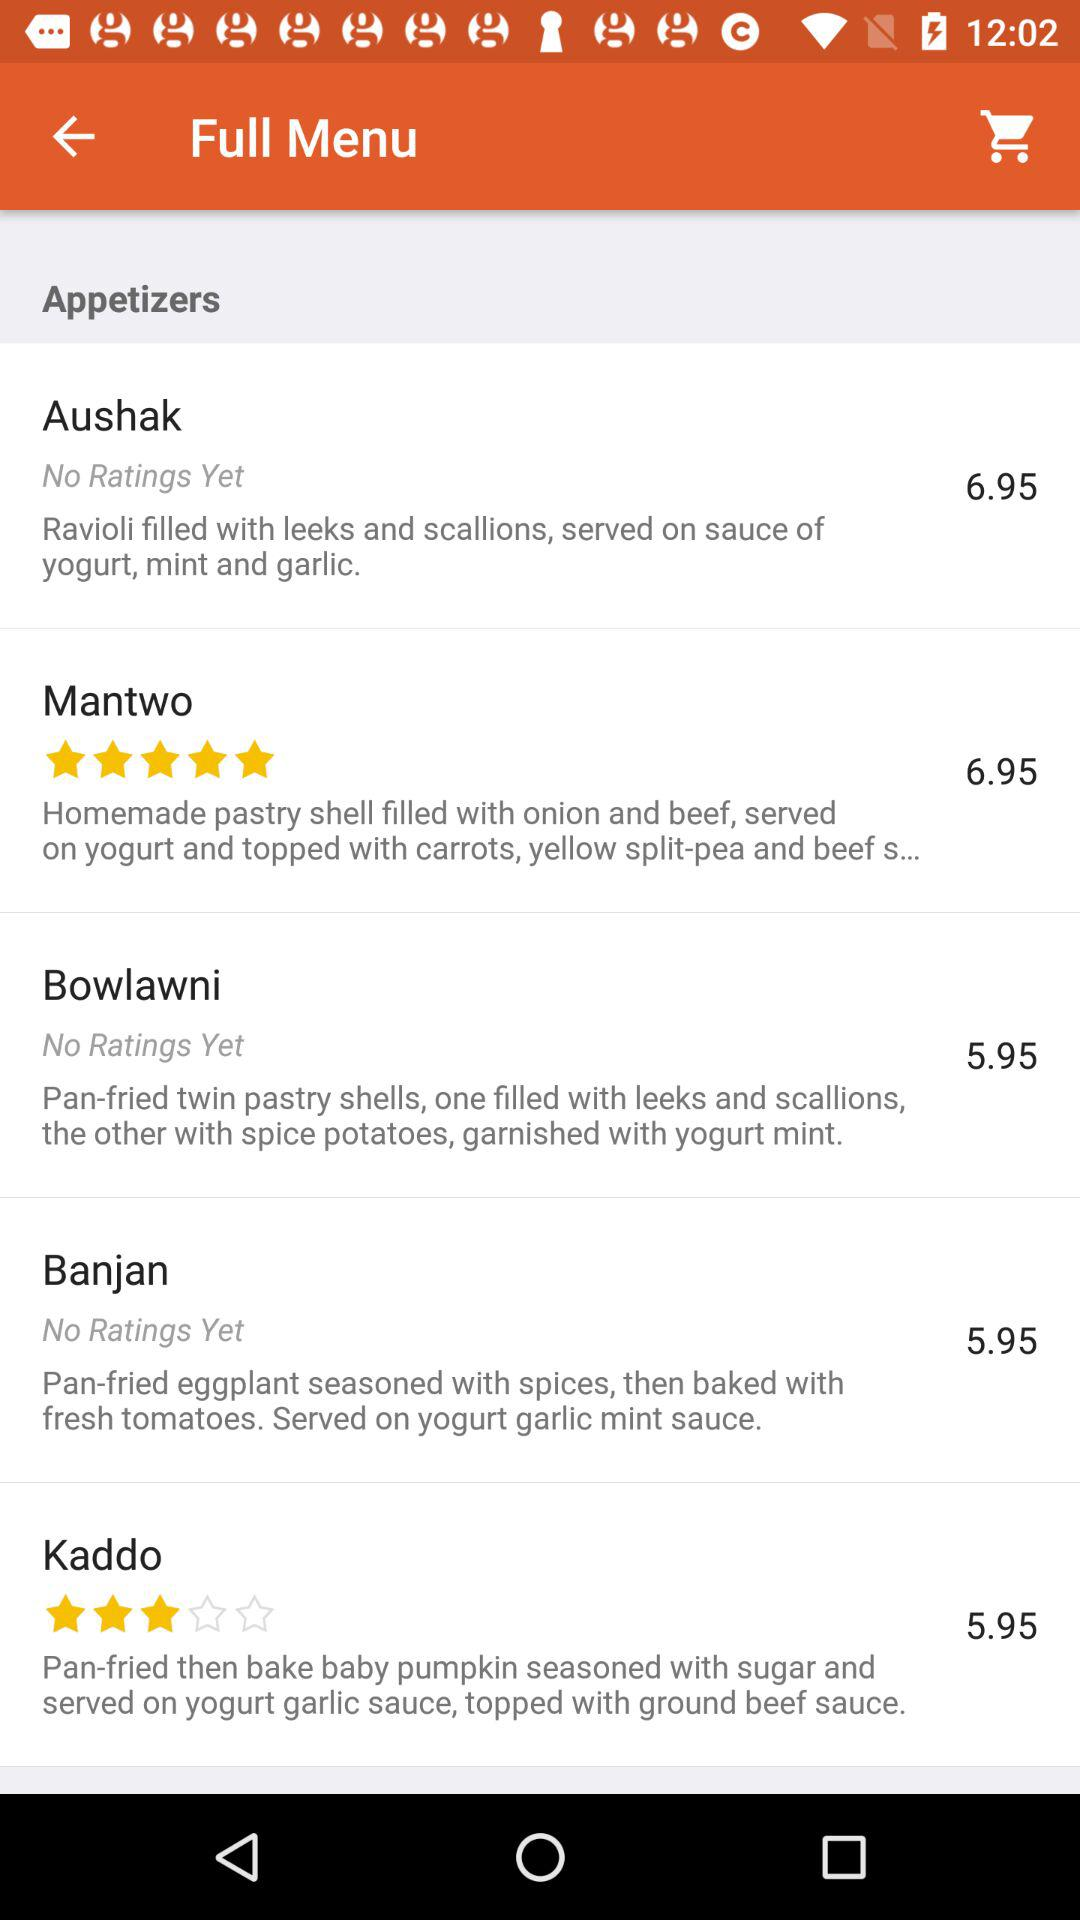How many items in the appetizer section have a price less than $6.00?
Answer the question using a single word or phrase. 3 